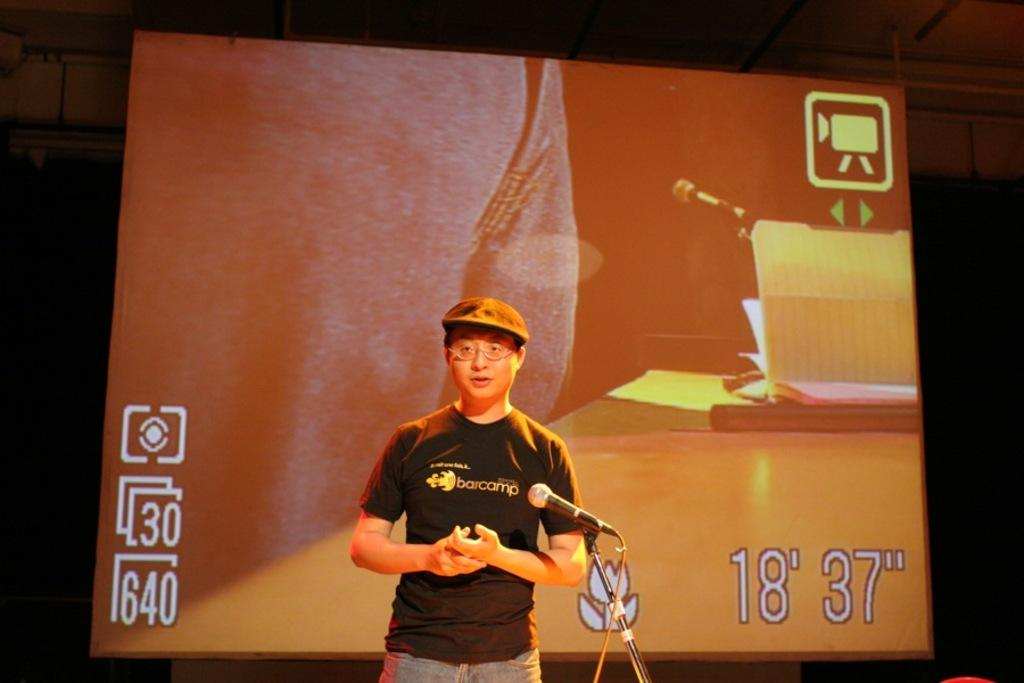What can be seen in the image? There is a person in the image. Can you describe the person's appearance? The person is wearing a cap and spectacles. What is the person doing in the image? The person is in front of a mic. What is visible in the background of the image? There is a screen and a roof visible in the background. What type of basin is visible in the image? There is no basin present in the image. Can you provide a suggestion for the person in the image? We cannot provide a suggestion for the person in the image, as we are only looking at the image and not interacting with the person. 